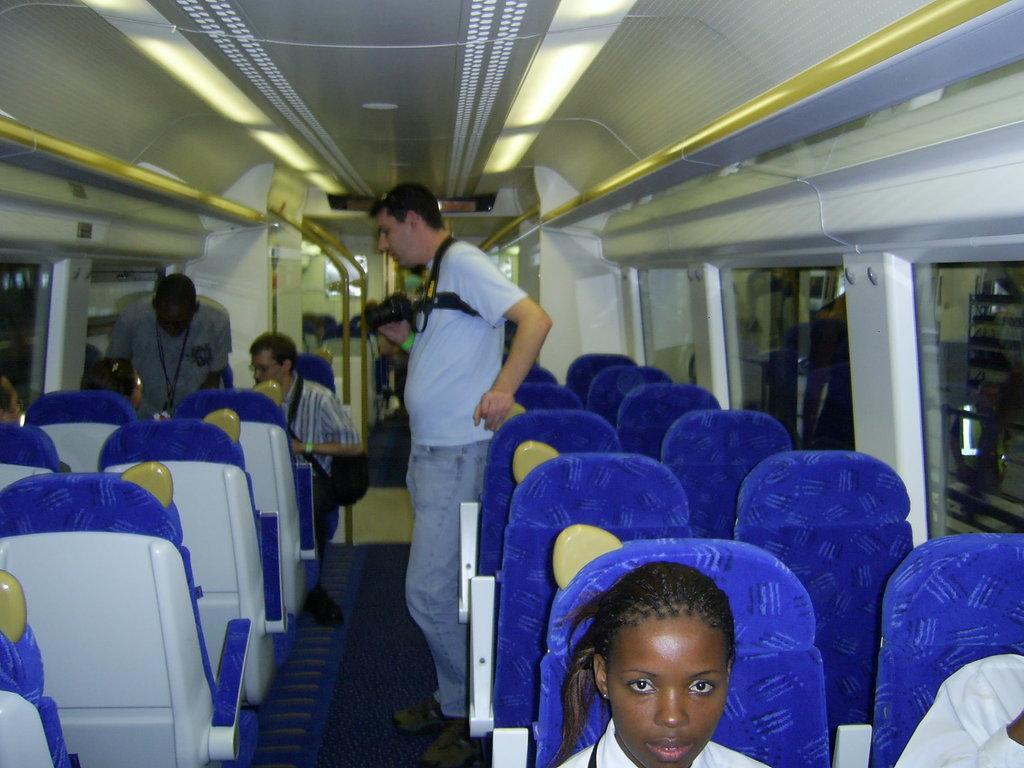Can you describe this image briefly? This picture is taken in the vehicle. Towards the left and right, there are blue seats. In the center, there is a man wearing a grey t shirt and holding a camera. At the bottom, there is a woman. On the top, there are lights. 